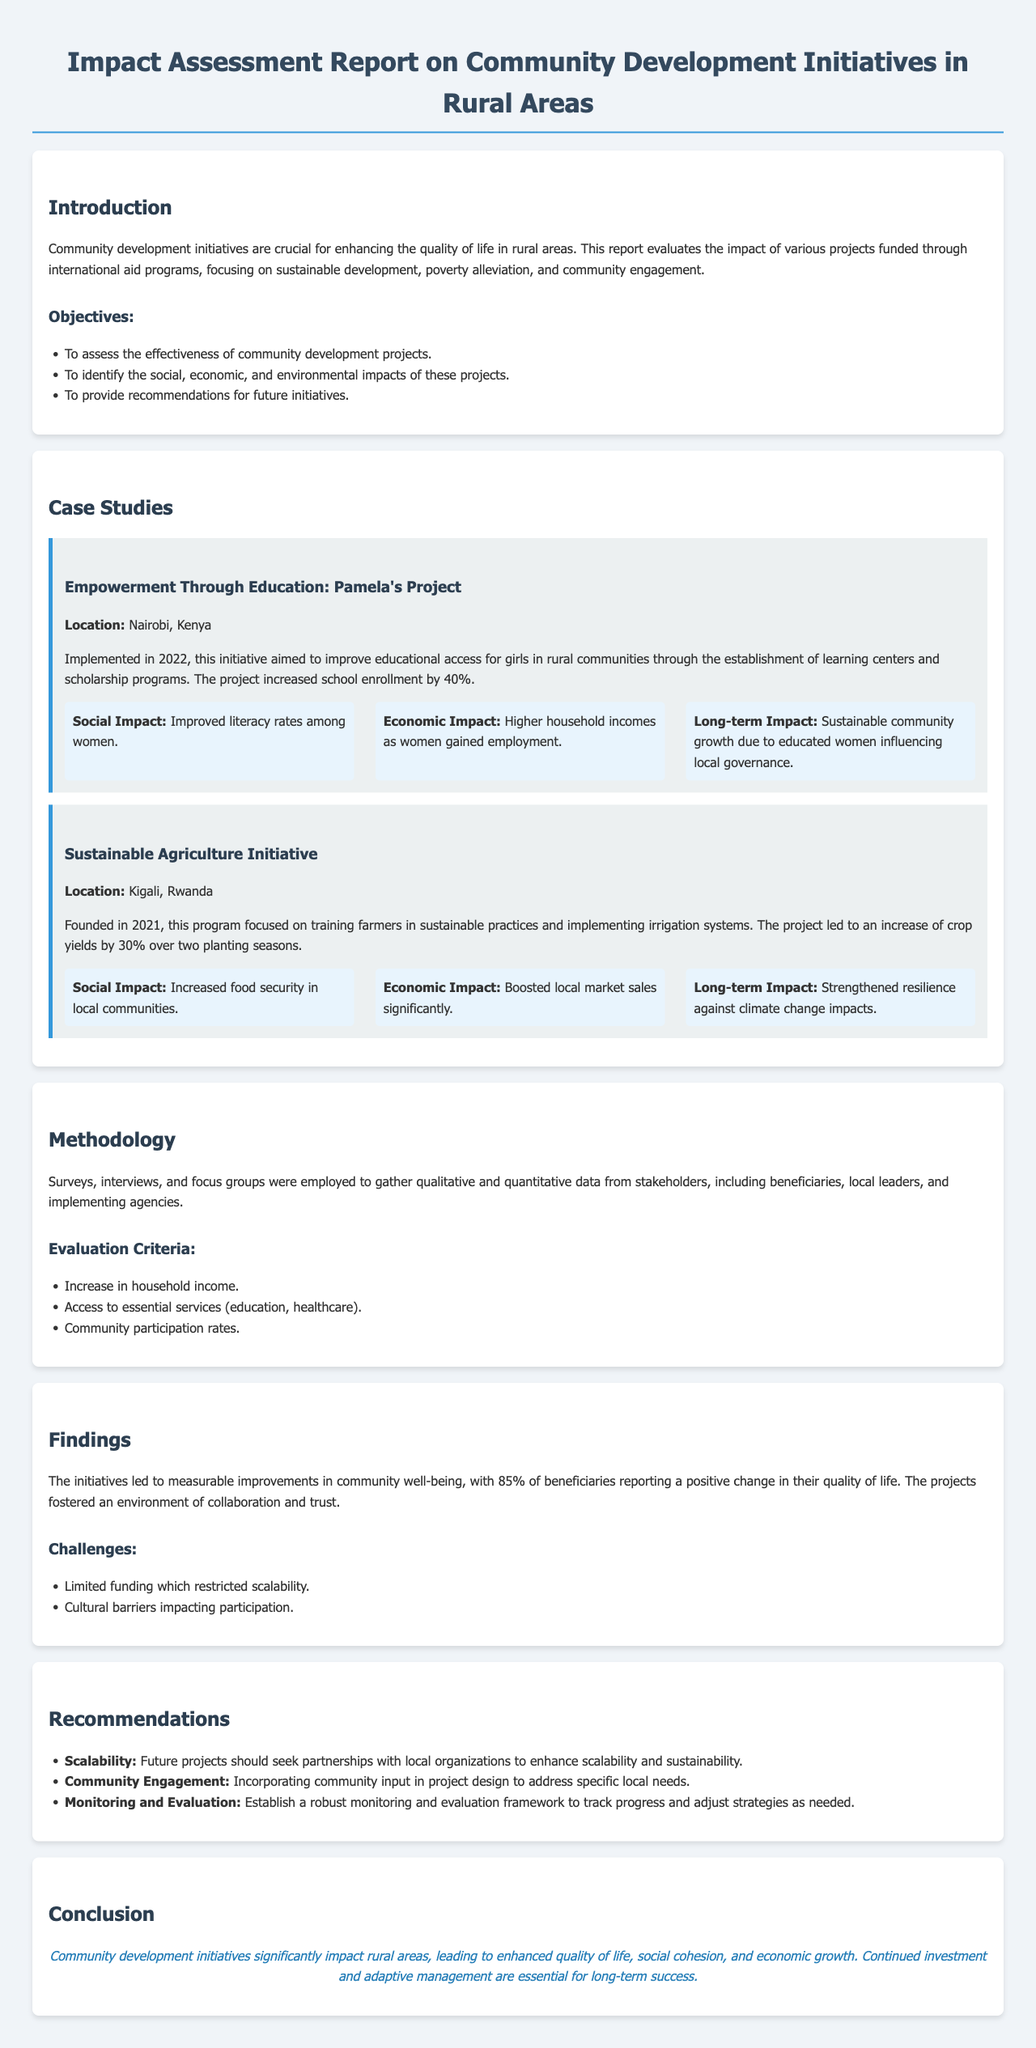What is the primary focus of the report? The report evaluates the impact of various projects funded through international aid programs, focusing on sustainable development, poverty alleviation, and community engagement.
Answer: Community development initiatives What percentage did school enrollment increase in Pamela's Project? The project increased school enrollment by 40%.
Answer: 40% What was the location of the Sustainable Agriculture Initiative? The location of the initiative is Kigali, Rwanda.
Answer: Kigali, Rwanda What was one evaluation criterion mentioned in the Methodology section? One evaluation criterion mentioned is access to essential services (education, healthcare).
Answer: Access to essential services What is one of the challenges faced by the initiatives? One challenge faced is limited funding which restricted scalability.
Answer: Limited funding What percentage of beneficiaries reported a positive change in their quality of life? 85% of beneficiaries reported a positive change in their quality of life.
Answer: 85% What recommendation is given for enhancing scalability? Future projects should seek partnerships with local organizations to enhance scalability and sustainability.
Answer: Partnerships with local organizations What impact did the Sustainable Agriculture Initiative have on crop yields? The project led to an increase of crop yields by 30% over two planting seasons.
Answer: 30% 